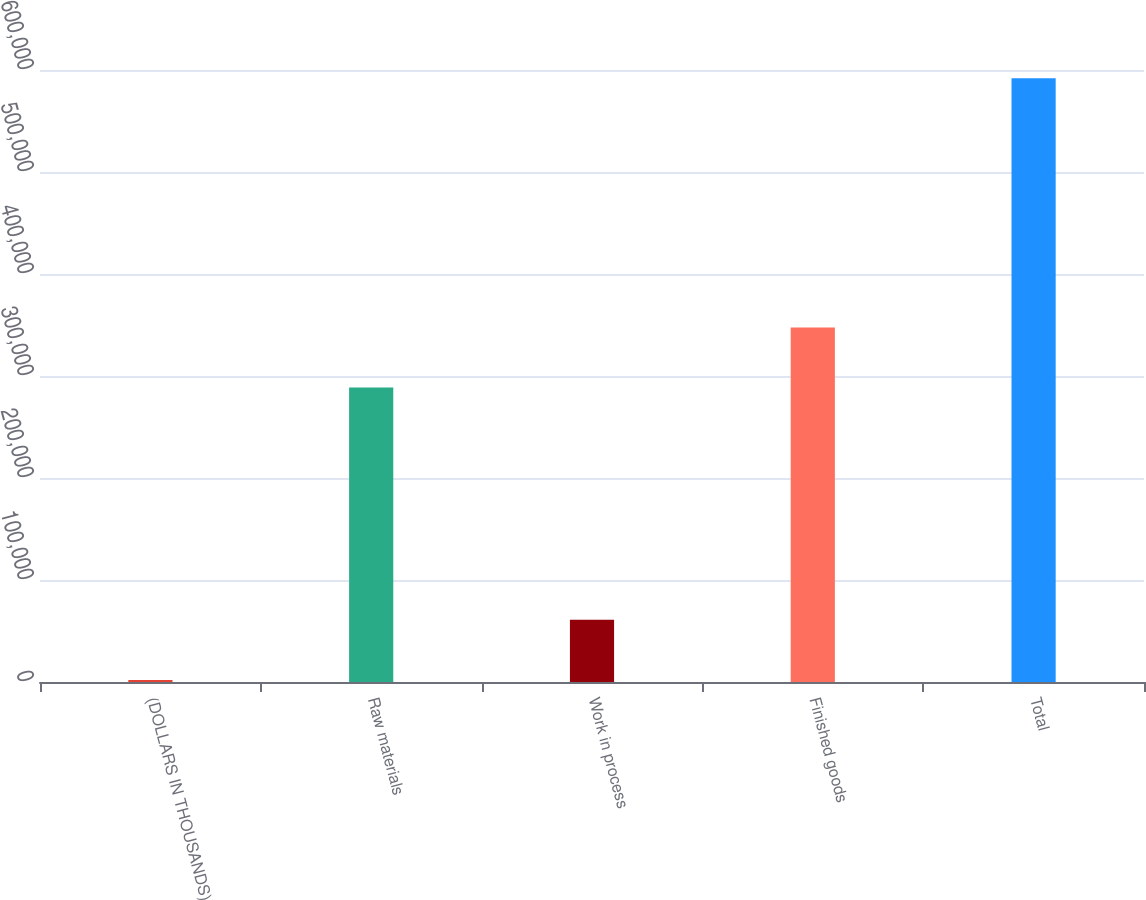Convert chart to OTSL. <chart><loc_0><loc_0><loc_500><loc_500><bar_chart><fcel>(DOLLARS IN THOUSANDS)<fcel>Raw materials<fcel>Work in process<fcel>Finished goods<fcel>Total<nl><fcel>2016<fcel>288629<fcel>61016.1<fcel>347629<fcel>592017<nl></chart> 